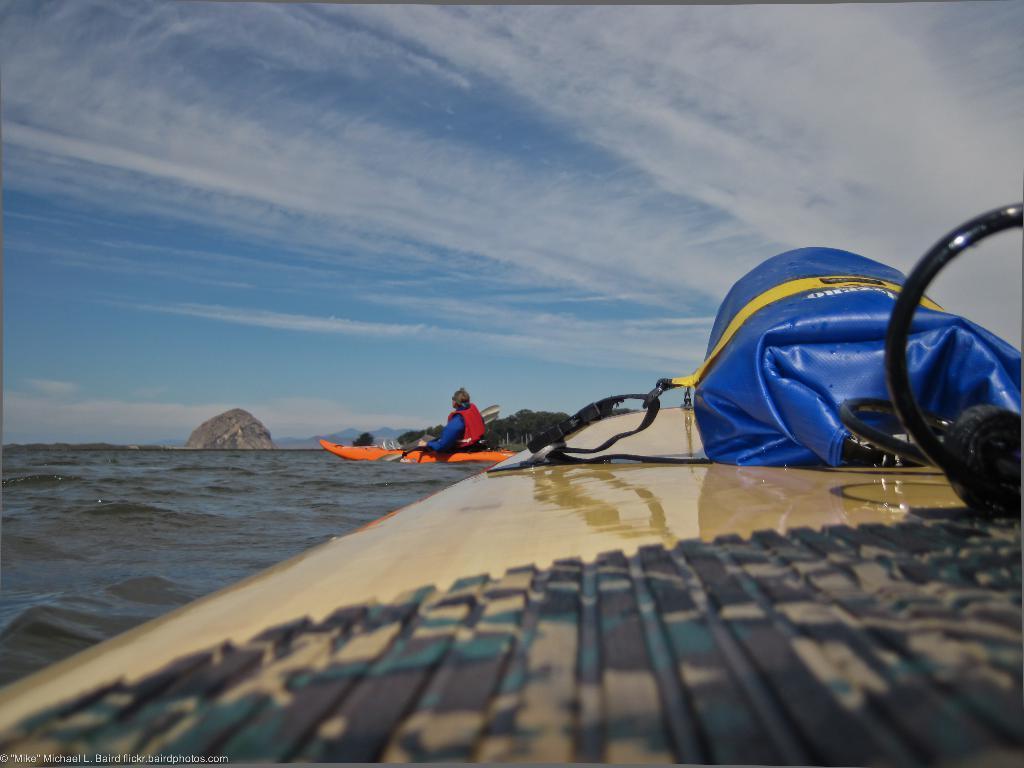In one or two sentences, can you explain what this image depicts? In this image we can see the blue color cover and some object are kept on the surface which is floating on the water. Here we can see a person wearing a life jacket and holding paddle is sitting on the orange color boat which is floating on the water. Here we can see rocks and blue color sky with clouds in the background. Here we can see the watermark on the bottom left side of the image. 